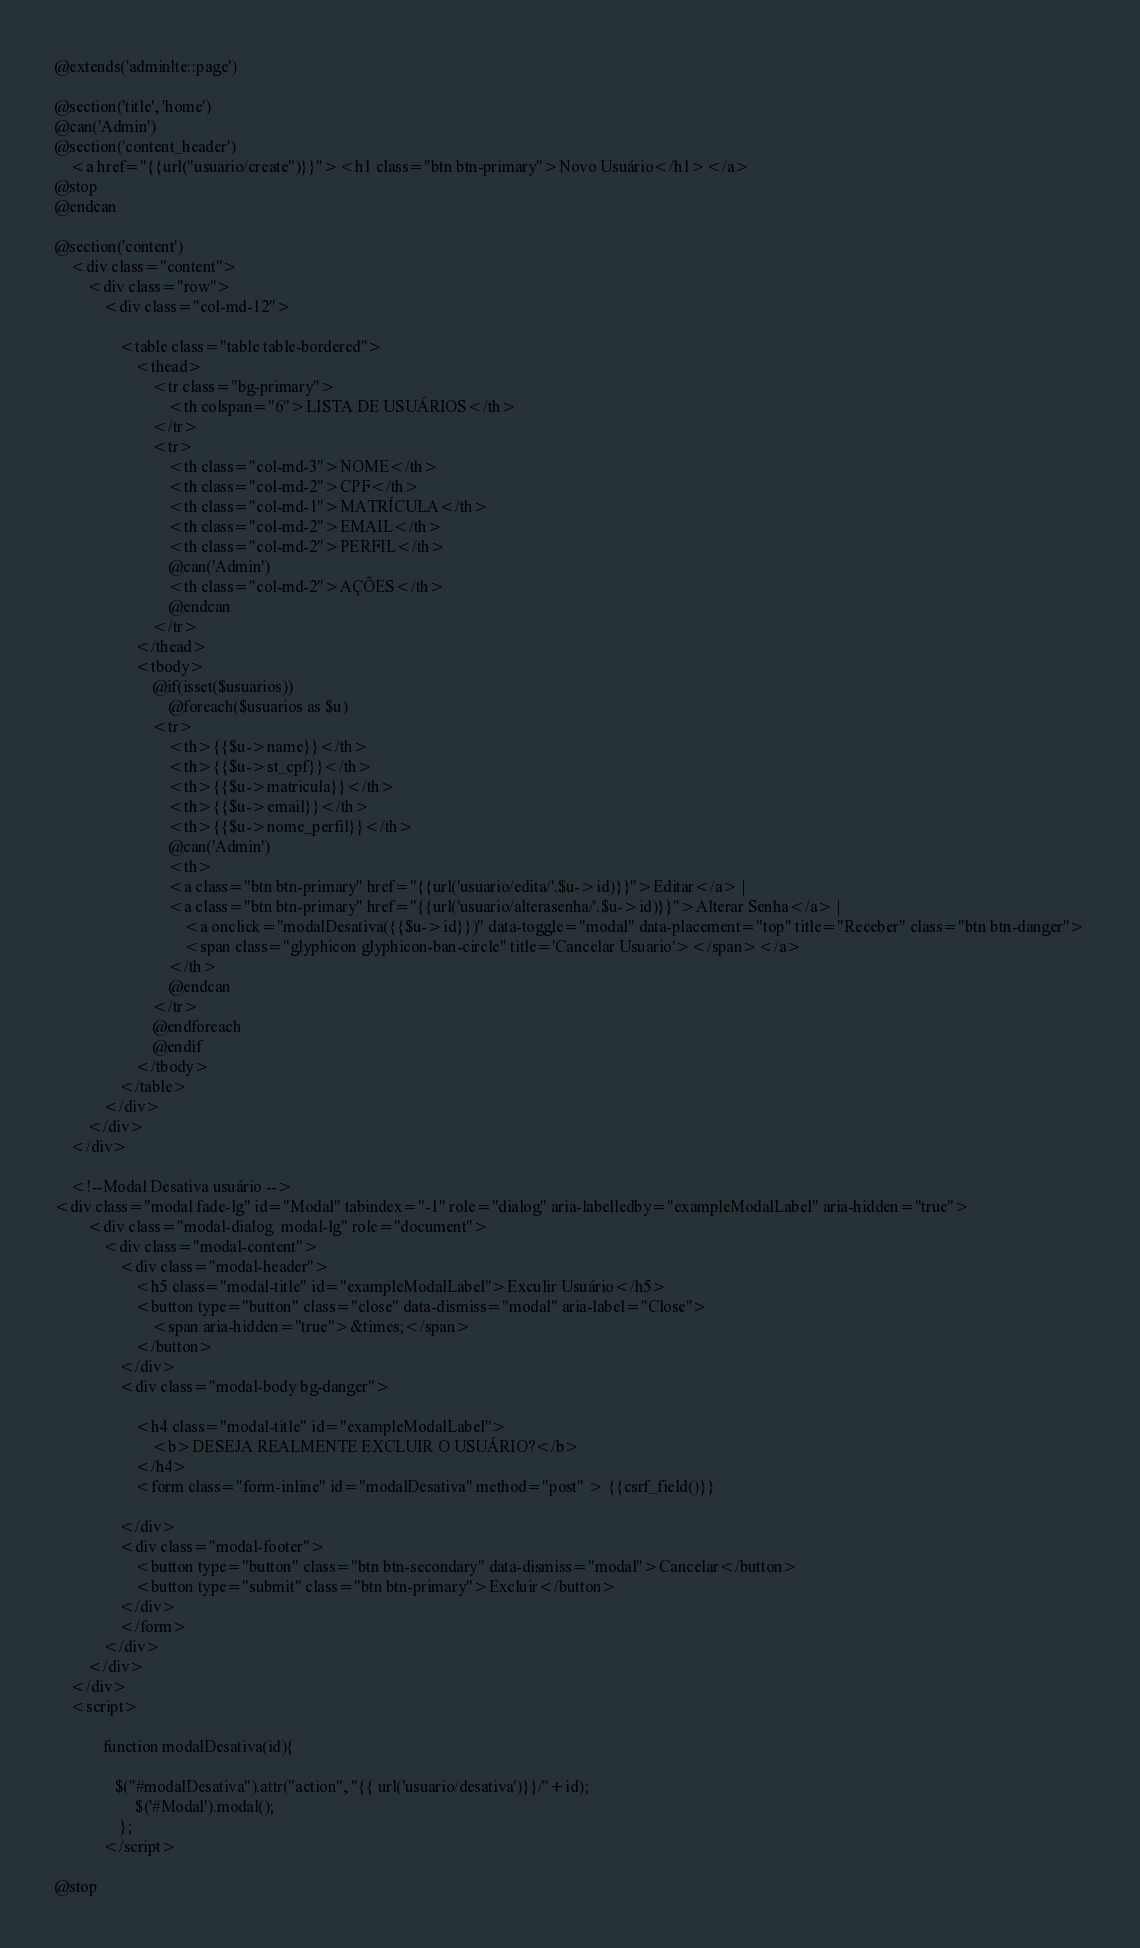Convert code to text. <code><loc_0><loc_0><loc_500><loc_500><_PHP_>@extends('adminlte::page')

@section('title', 'home')
@can('Admin')
@section('content_header')
    <a href="{{url("usuario/create")}}"><h1 class="btn btn-primary">Novo Usuário</h1></a>
@stop
@endcan

@section('content')
    <div class="content">
        <div class="row">
            <div class="col-md-12">

                <table class="table table-bordered">
                    <thead>
                        <tr class="bg-primary">
                            <th colspan="6">LISTA DE USUÁRIOS</th>
                        </tr>
                        <tr>
                            <th class="col-md-3">NOME</th>
                            <th class="col-md-2">CPF</th>
                            <th class="col-md-1">MATRÍCULA</th>
                            <th class="col-md-2">EMAIL</th>
                            <th class="col-md-2">PERFIL</th>
                            @can('Admin')
                            <th class="col-md-2">AÇÕES</th>
                            @endcan
                        </tr>
                    </thead>
                    <tbody>
                        @if(isset($usuarios))
                            @foreach($usuarios as $u)
                        <tr>
                            <th>{{$u->name}}</th>
                            <th>{{$u->st_cpf}}</th>
                            <th>{{$u->matricula}}</th>
                            <th>{{$u->email}}</th>
                            <th>{{$u->nome_perfil}}</th>
                            @can('Admin')
                            <th>
							<a class="btn btn-primary" href="{{url('usuario/edita/'.$u->id)}}">Editar</a> | 
							<a class="btn btn-primary" href="{{url('usuario/alterasenha/'.$u->id)}}">Alterar Senha</a> |
                                <a onclick="modalDesativa({{$u->id}})" data-toggle="modal" data-placement="top" title="Receber" class="btn btn-danger">
                                <span class="glyphicon glyphicon-ban-circle" title='Cancelar Usuario'></span></a> 
                            </th>
                            @endcan
                        </tr>
                        @endforeach
                        @endif
                    </tbody>
                </table>
            </div>
        </div>
    </div>

    <!--Modal Desativa usuário -->
<div class="modal fade-lg" id="Modal" tabindex="-1" role="dialog" aria-labelledby="exampleModalLabel" aria-hidden="true">
        <div class="modal-dialog  modal-lg" role="document">
            <div class="modal-content">
                <div class="modal-header">
                    <h5 class="modal-title" id="exampleModalLabel">Exculir Usuário</h5>
                    <button type="button" class="close" data-dismiss="modal" aria-label="Close">
                        <span aria-hidden="true">&times;</span>
                    </button>
                </div>
                <div class="modal-body bg-danger">
    
                    <h4 class="modal-title" id="exampleModalLabel">
                        <b>DESEJA REALMENTE EXCLUIR O USUÁRIO?</b>
                    </h4>
                    <form class="form-inline" id="modalDesativa" method="post" > {{csrf_field()}}
    
                </div>
                <div class="modal-footer">
                    <button type="button" class="btn btn-secondary" data-dismiss="modal">Cancelar</button>
                    <button type="submit" class="btn btn-primary">Excluir</button>
                </div>
                </form>
            </div>
        </div>
    </div>
    <script>
  
            function modalDesativa(id){
               
               $("#modalDesativa").attr("action", "{{ url('usuario/desativa')}}/"+id);
                    $('#Modal').modal();        
                };
            </script>

@stop</code> 